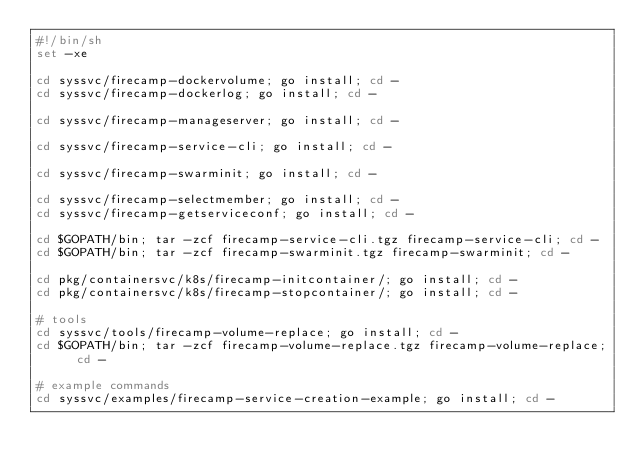<code> <loc_0><loc_0><loc_500><loc_500><_Bash_>#!/bin/sh
set -xe

cd syssvc/firecamp-dockervolume; go install; cd -
cd syssvc/firecamp-dockerlog; go install; cd -

cd syssvc/firecamp-manageserver; go install; cd -

cd syssvc/firecamp-service-cli; go install; cd -

cd syssvc/firecamp-swarminit; go install; cd -

cd syssvc/firecamp-selectmember; go install; cd -
cd syssvc/firecamp-getserviceconf; go install; cd -

cd $GOPATH/bin; tar -zcf firecamp-service-cli.tgz firecamp-service-cli; cd -
cd $GOPATH/bin; tar -zcf firecamp-swarminit.tgz firecamp-swarminit; cd -

cd pkg/containersvc/k8s/firecamp-initcontainer/; go install; cd -
cd pkg/containersvc/k8s/firecamp-stopcontainer/; go install; cd -

# tools
cd syssvc/tools/firecamp-volume-replace; go install; cd -
cd $GOPATH/bin; tar -zcf firecamp-volume-replace.tgz firecamp-volume-replace; cd -

# example commands
cd syssvc/examples/firecamp-service-creation-example; go install; cd -
</code> 